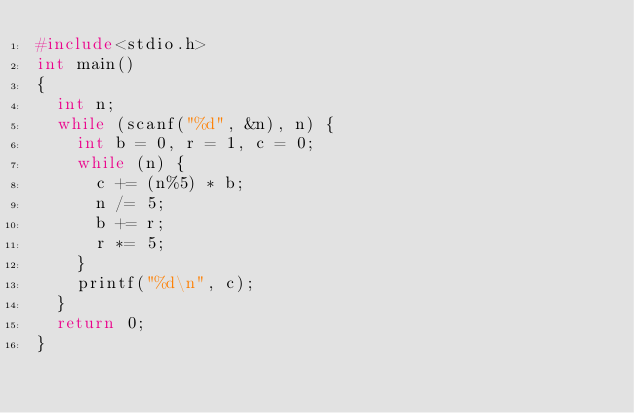Convert code to text. <code><loc_0><loc_0><loc_500><loc_500><_C++_>#include<stdio.h>
int main()
{
	int n;
	while (scanf("%d", &n), n) {
		int b = 0, r = 1, c = 0;
		while (n) {
			c += (n%5) * b;
			n /= 5;
			b += r;
			r *= 5;
		}
		printf("%d\n", c);
	}
	return 0;
}</code> 